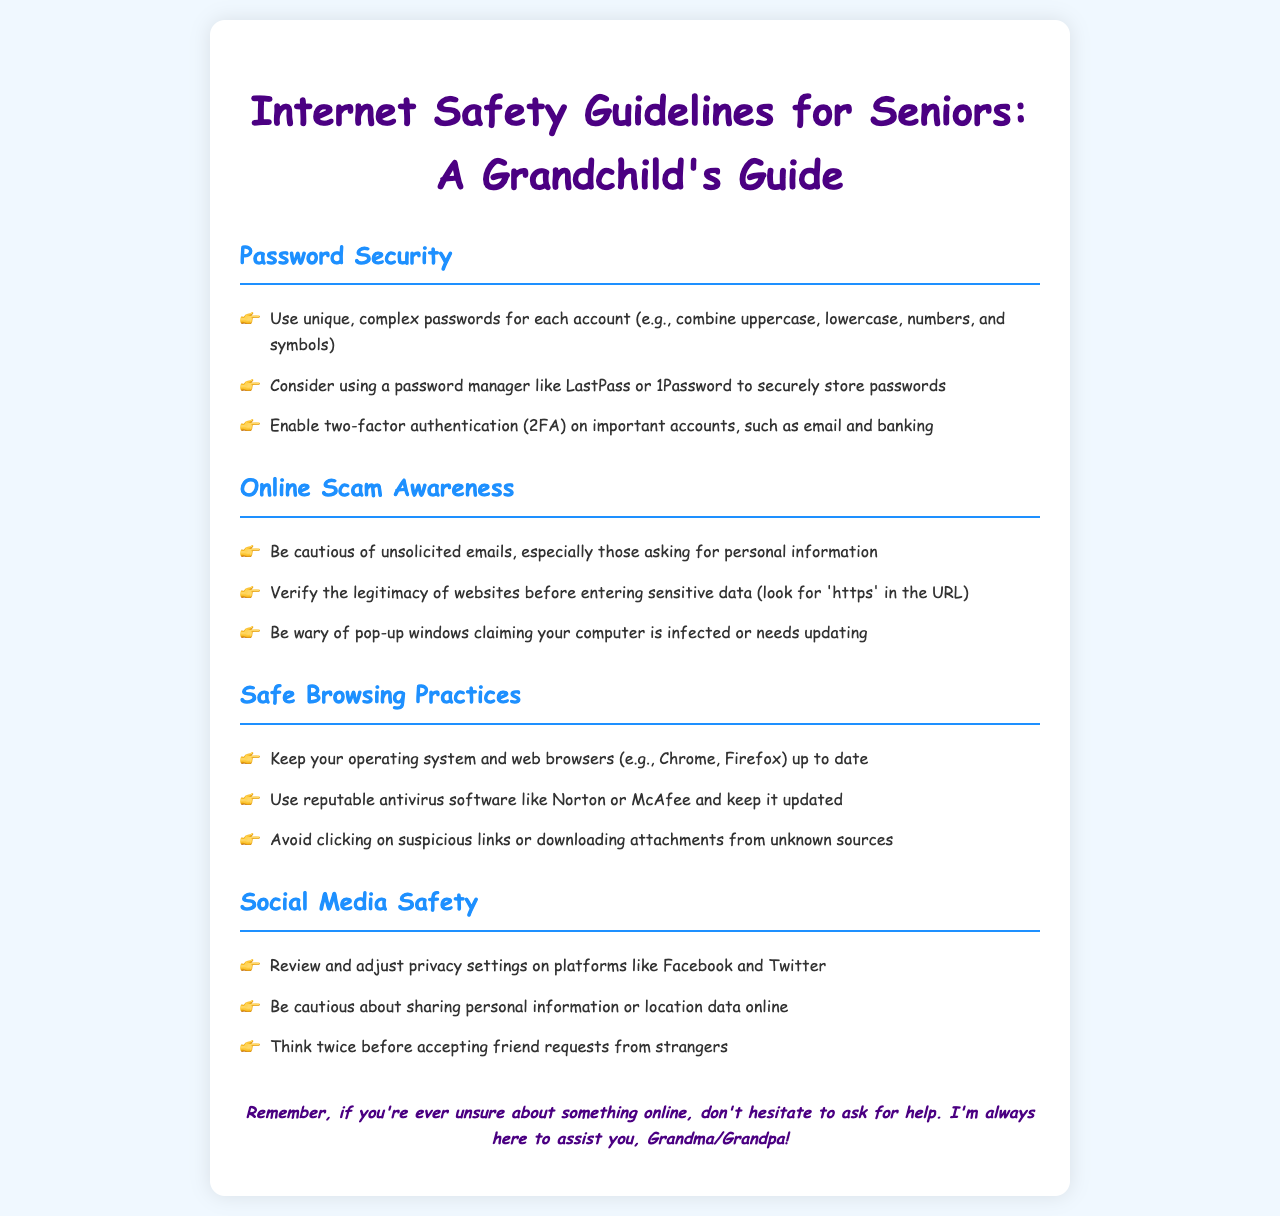What are the three aspects of password security mentioned? The document outlines three aspects of password security: unique passwords, password manager, and two-factor authentication.
Answer: unique passwords, password manager, two-factor authentication What should you use to store passwords securely? The document suggests using a password manager like LastPass or 1Password for secure password storage.
Answer: password manager like LastPass or 1Password What does 'https' indicate about a website? The presence of 'https' in a URL suggests that the website is secure and legitimate, which is important for entering sensitive data.
Answer: secure What should you do before accepting friend requests from strangers? The document advises thinking twice before accepting friend requests from strangers to ensure online safety.
Answer: think twice How many areas of safety does the document cover? The document covers four specific areas of safety guidelines relevant to seniors using the internet.
Answer: four 